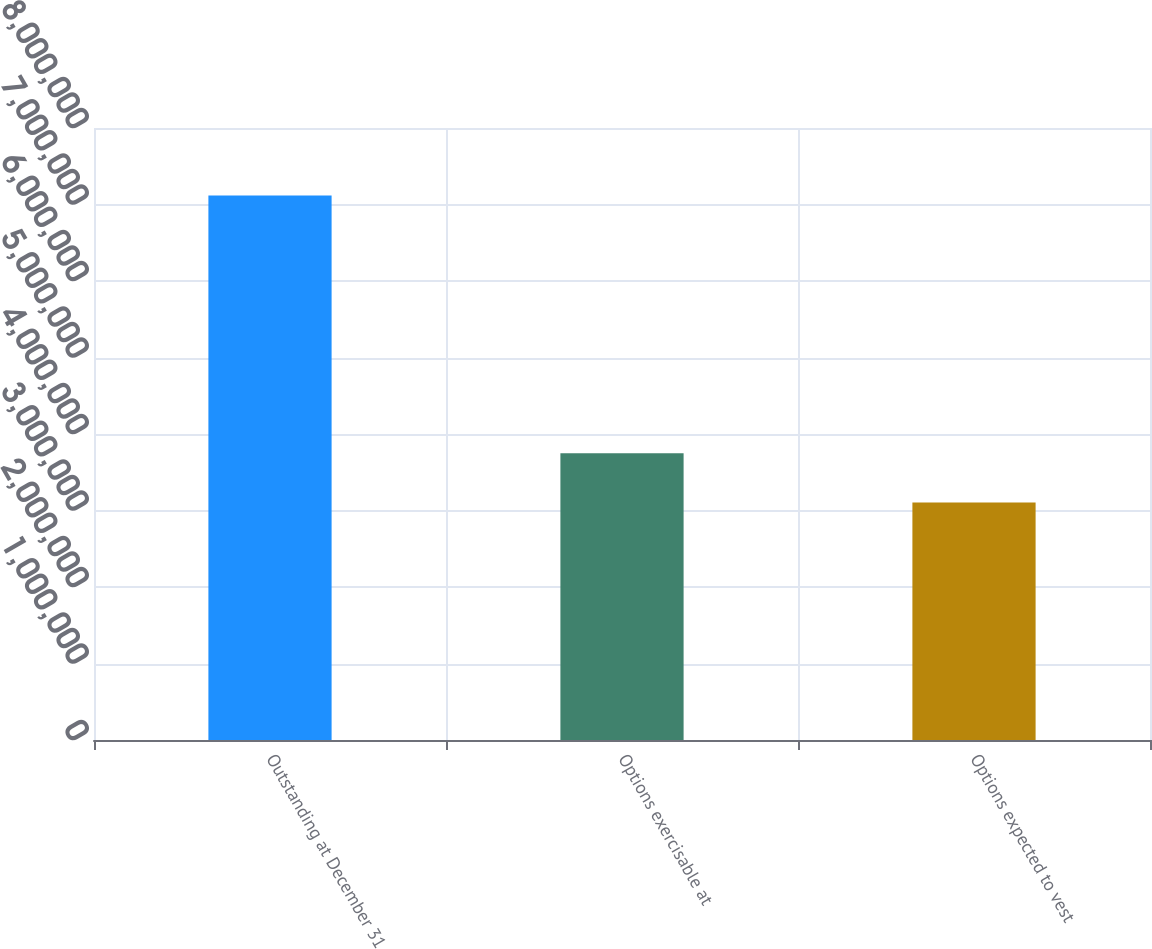<chart> <loc_0><loc_0><loc_500><loc_500><bar_chart><fcel>Outstanding at December 31<fcel>Options exercisable at<fcel>Options expected to vest<nl><fcel>7.11846e+06<fcel>3.74948e+06<fcel>3.10354e+06<nl></chart> 